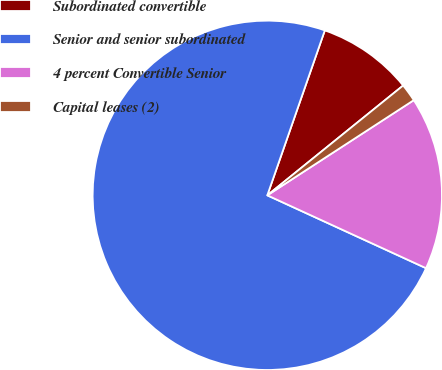Convert chart to OTSL. <chart><loc_0><loc_0><loc_500><loc_500><pie_chart><fcel>Subordinated convertible<fcel>Senior and senior subordinated<fcel>4 percent Convertible Senior<fcel>Capital leases (2)<nl><fcel>8.84%<fcel>73.49%<fcel>16.02%<fcel>1.65%<nl></chart> 